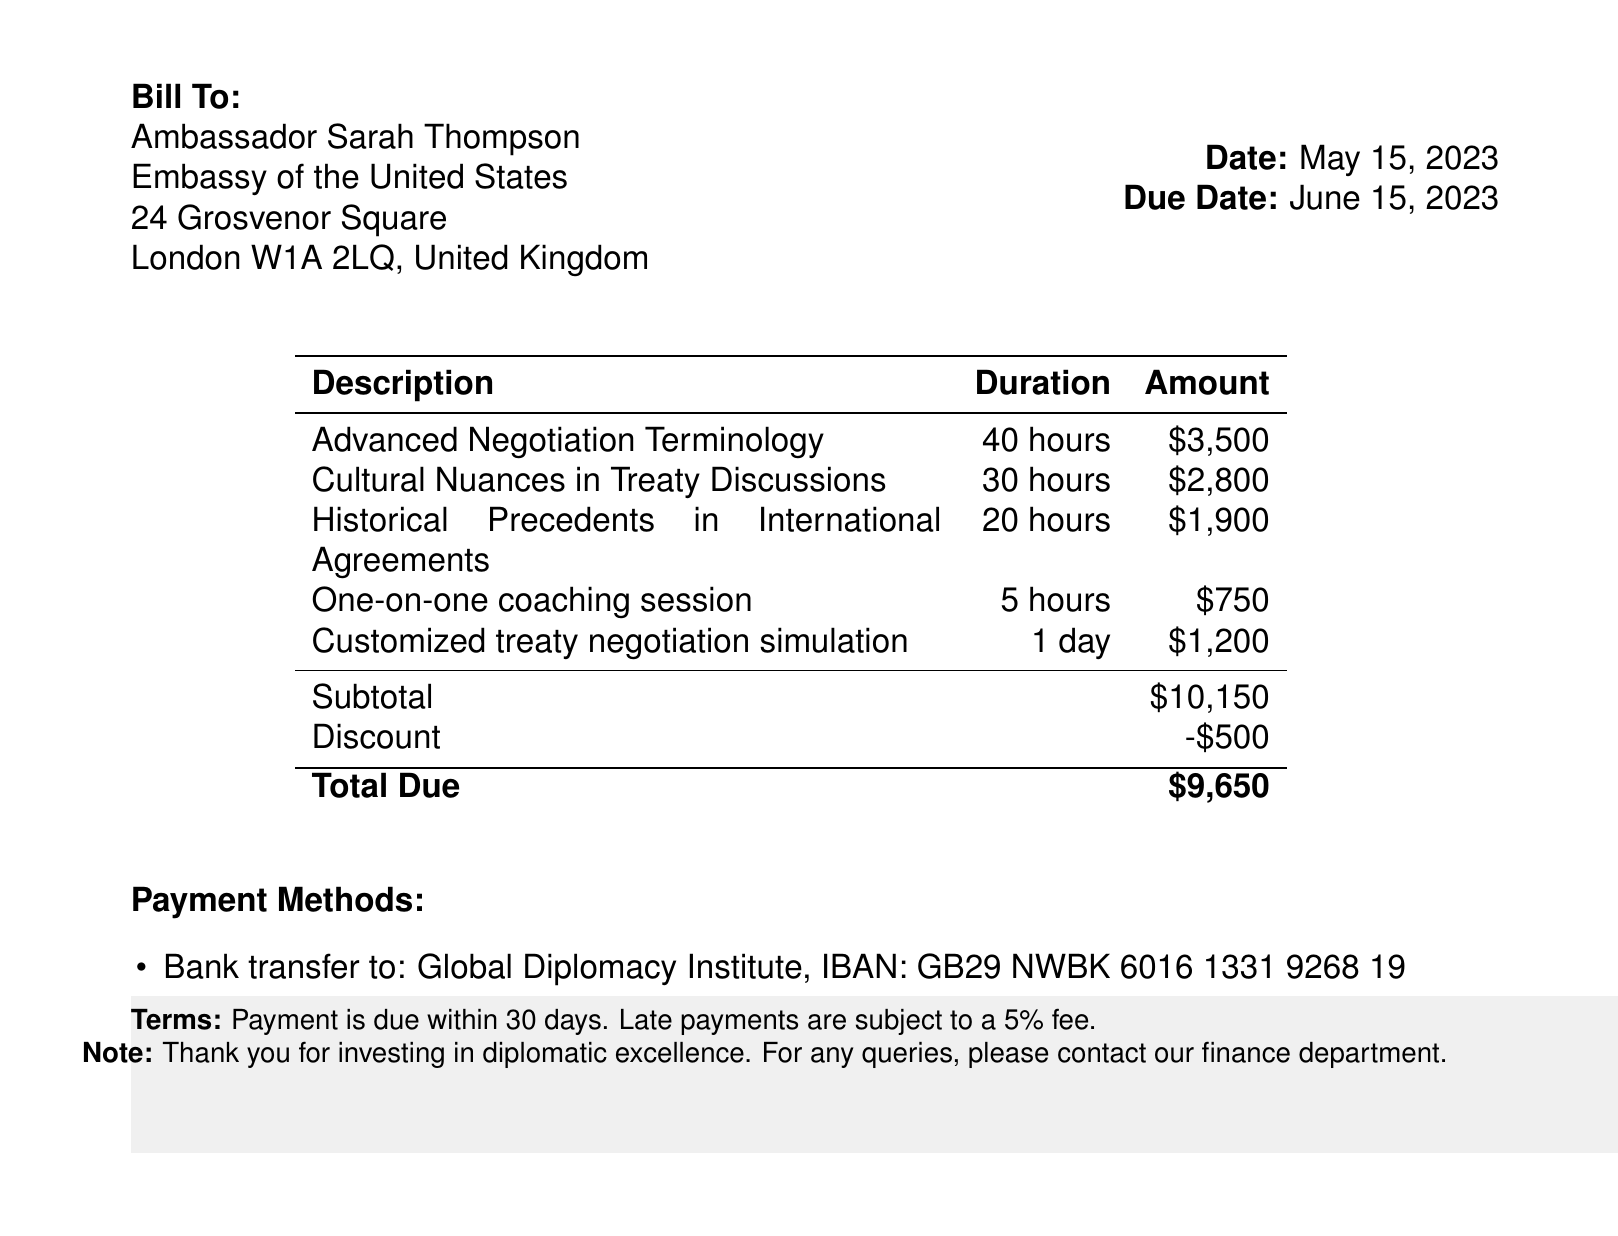What is the total amount due? The total amount due is listed at the bottom of the invoice after calculating the subtotal and applying the discount.
Answer: $9,650 Who is the invoice billed to? The document states that the bill is addressed to Ambassador Sarah Thompson specifically, including her diplomatic affiliation.
Answer: Ambassador Sarah Thompson What is the due date of the invoice? The due date is specified next to the date of the invoice, marking the deadline for payment.
Answer: June 15, 2023 How many hours of training are provided for Cultural Nuances in Treaty Discussions? This information can be found in the training description section, which lists hours for each course.
Answer: 30 hours What is the amount charged for one-on-one coaching sessions? The amount for this specific service is clearly indicated in the table with the course descriptions.
Answer: $750 What payment methods are available? This section outlines two methods for making payments in response to the invoice and can be found at the end of the document.
Answer: Bank transfer and credit card What is the discount applied to the subtotal? This detail can be determined from the discount line item included below the subtotal in the invoice.
Answer: $500 What is the duration of the Advanced Negotiation Terminology course? The duration of each course is listed in the second column of the table.
Answer: 40 hours 